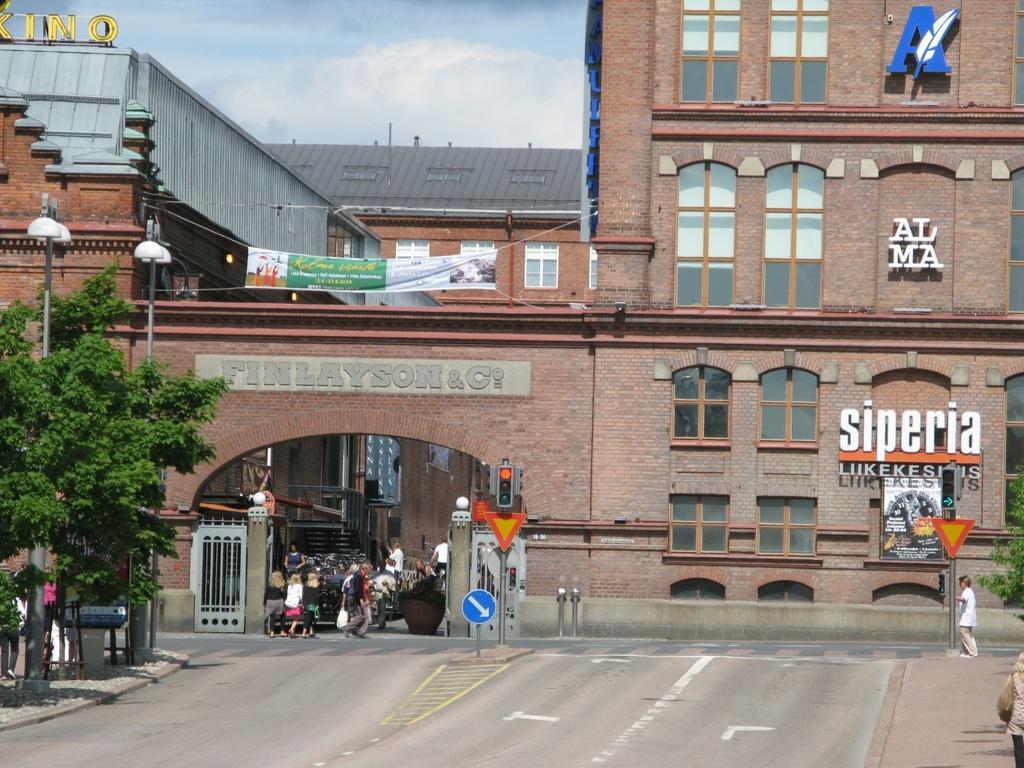Can you describe this image briefly? At the bottom there are few persons walking on the road, sign board poles, traffic signal poles, trees on the left and right side. In the background we can see buildings, hoardings on the wall, banner, light poles, windows, roof, gate and clouds in the sky. 